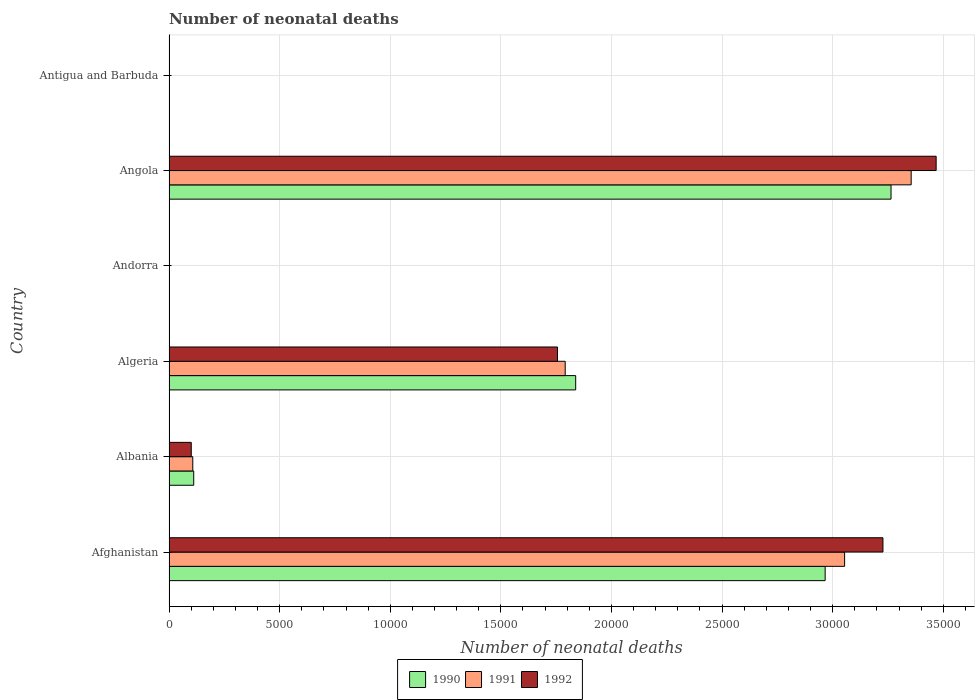How many different coloured bars are there?
Your answer should be very brief. 3. How many groups of bars are there?
Provide a succinct answer. 6. Are the number of bars on each tick of the Y-axis equal?
Offer a terse response. Yes. What is the label of the 2nd group of bars from the top?
Provide a succinct answer. Angola. In how many cases, is the number of bars for a given country not equal to the number of legend labels?
Give a very brief answer. 0. What is the number of neonatal deaths in in 1992 in Albania?
Make the answer very short. 1006. Across all countries, what is the maximum number of neonatal deaths in in 1991?
Your answer should be compact. 3.35e+04. Across all countries, what is the minimum number of neonatal deaths in in 1992?
Provide a short and direct response. 2. In which country was the number of neonatal deaths in in 1992 maximum?
Your answer should be very brief. Angola. In which country was the number of neonatal deaths in in 1992 minimum?
Ensure brevity in your answer.  Andorra. What is the total number of neonatal deaths in in 1990 in the graph?
Give a very brief answer. 8.18e+04. What is the difference between the number of neonatal deaths in in 1992 in Albania and that in Andorra?
Provide a short and direct response. 1004. What is the difference between the number of neonatal deaths in in 1991 in Antigua and Barbuda and the number of neonatal deaths in in 1992 in Angola?
Provide a succinct answer. -3.47e+04. What is the average number of neonatal deaths in in 1992 per country?
Ensure brevity in your answer.  1.43e+04. What is the difference between the number of neonatal deaths in in 1990 and number of neonatal deaths in in 1992 in Andorra?
Your answer should be compact. 0. What is the ratio of the number of neonatal deaths in in 1990 in Albania to that in Algeria?
Make the answer very short. 0.06. What is the difference between the highest and the second highest number of neonatal deaths in in 1992?
Your answer should be compact. 2404. What is the difference between the highest and the lowest number of neonatal deaths in in 1992?
Offer a terse response. 3.47e+04. In how many countries, is the number of neonatal deaths in in 1992 greater than the average number of neonatal deaths in in 1992 taken over all countries?
Offer a very short reply. 3. Is the sum of the number of neonatal deaths in in 1990 in Albania and Antigua and Barbuda greater than the maximum number of neonatal deaths in in 1992 across all countries?
Provide a short and direct response. No. What does the 1st bar from the top in Angola represents?
Make the answer very short. 1992. Are all the bars in the graph horizontal?
Your answer should be compact. Yes. Are the values on the major ticks of X-axis written in scientific E-notation?
Your answer should be compact. No. What is the title of the graph?
Your answer should be very brief. Number of neonatal deaths. What is the label or title of the X-axis?
Offer a very short reply. Number of neonatal deaths. What is the label or title of the Y-axis?
Provide a short and direct response. Country. What is the Number of neonatal deaths in 1990 in Afghanistan?
Your response must be concise. 2.97e+04. What is the Number of neonatal deaths of 1991 in Afghanistan?
Your answer should be compact. 3.05e+04. What is the Number of neonatal deaths in 1992 in Afghanistan?
Provide a short and direct response. 3.23e+04. What is the Number of neonatal deaths of 1990 in Albania?
Ensure brevity in your answer.  1117. What is the Number of neonatal deaths of 1991 in Albania?
Ensure brevity in your answer.  1075. What is the Number of neonatal deaths of 1992 in Albania?
Ensure brevity in your answer.  1006. What is the Number of neonatal deaths in 1990 in Algeria?
Your answer should be very brief. 1.84e+04. What is the Number of neonatal deaths of 1991 in Algeria?
Provide a succinct answer. 1.79e+04. What is the Number of neonatal deaths in 1992 in Algeria?
Offer a terse response. 1.76e+04. What is the Number of neonatal deaths of 1990 in Andorra?
Your answer should be very brief. 2. What is the Number of neonatal deaths of 1992 in Andorra?
Your answer should be very brief. 2. What is the Number of neonatal deaths in 1990 in Angola?
Ensure brevity in your answer.  3.26e+04. What is the Number of neonatal deaths in 1991 in Angola?
Make the answer very short. 3.35e+04. What is the Number of neonatal deaths of 1992 in Angola?
Provide a short and direct response. 3.47e+04. Across all countries, what is the maximum Number of neonatal deaths in 1990?
Offer a terse response. 3.26e+04. Across all countries, what is the maximum Number of neonatal deaths in 1991?
Your response must be concise. 3.35e+04. Across all countries, what is the maximum Number of neonatal deaths in 1992?
Your response must be concise. 3.47e+04. Across all countries, what is the minimum Number of neonatal deaths of 1991?
Give a very brief answer. 2. What is the total Number of neonatal deaths in 1990 in the graph?
Keep it short and to the point. 8.18e+04. What is the total Number of neonatal deaths in 1991 in the graph?
Give a very brief answer. 8.31e+04. What is the total Number of neonatal deaths in 1992 in the graph?
Keep it short and to the point. 8.55e+04. What is the difference between the Number of neonatal deaths of 1990 in Afghanistan and that in Albania?
Give a very brief answer. 2.85e+04. What is the difference between the Number of neonatal deaths of 1991 in Afghanistan and that in Albania?
Give a very brief answer. 2.95e+04. What is the difference between the Number of neonatal deaths in 1992 in Afghanistan and that in Albania?
Provide a succinct answer. 3.13e+04. What is the difference between the Number of neonatal deaths in 1990 in Afghanistan and that in Algeria?
Make the answer very short. 1.13e+04. What is the difference between the Number of neonatal deaths of 1991 in Afghanistan and that in Algeria?
Keep it short and to the point. 1.26e+04. What is the difference between the Number of neonatal deaths in 1992 in Afghanistan and that in Algeria?
Provide a short and direct response. 1.47e+04. What is the difference between the Number of neonatal deaths in 1990 in Afghanistan and that in Andorra?
Your answer should be very brief. 2.97e+04. What is the difference between the Number of neonatal deaths in 1991 in Afghanistan and that in Andorra?
Your response must be concise. 3.05e+04. What is the difference between the Number of neonatal deaths in 1992 in Afghanistan and that in Andorra?
Provide a short and direct response. 3.23e+04. What is the difference between the Number of neonatal deaths in 1990 in Afghanistan and that in Angola?
Your response must be concise. -2977. What is the difference between the Number of neonatal deaths in 1991 in Afghanistan and that in Angola?
Offer a very short reply. -3009. What is the difference between the Number of neonatal deaths of 1992 in Afghanistan and that in Angola?
Your answer should be compact. -2404. What is the difference between the Number of neonatal deaths in 1990 in Afghanistan and that in Antigua and Barbuda?
Offer a terse response. 2.96e+04. What is the difference between the Number of neonatal deaths in 1991 in Afghanistan and that in Antigua and Barbuda?
Offer a very short reply. 3.05e+04. What is the difference between the Number of neonatal deaths of 1992 in Afghanistan and that in Antigua and Barbuda?
Provide a succinct answer. 3.23e+04. What is the difference between the Number of neonatal deaths of 1990 in Albania and that in Algeria?
Your answer should be very brief. -1.73e+04. What is the difference between the Number of neonatal deaths in 1991 in Albania and that in Algeria?
Offer a terse response. -1.68e+04. What is the difference between the Number of neonatal deaths in 1992 in Albania and that in Algeria?
Keep it short and to the point. -1.66e+04. What is the difference between the Number of neonatal deaths of 1990 in Albania and that in Andorra?
Your answer should be compact. 1115. What is the difference between the Number of neonatal deaths in 1991 in Albania and that in Andorra?
Offer a terse response. 1073. What is the difference between the Number of neonatal deaths of 1992 in Albania and that in Andorra?
Offer a very short reply. 1004. What is the difference between the Number of neonatal deaths of 1990 in Albania and that in Angola?
Make the answer very short. -3.15e+04. What is the difference between the Number of neonatal deaths of 1991 in Albania and that in Angola?
Give a very brief answer. -3.25e+04. What is the difference between the Number of neonatal deaths of 1992 in Albania and that in Angola?
Offer a very short reply. -3.37e+04. What is the difference between the Number of neonatal deaths of 1990 in Albania and that in Antigua and Barbuda?
Provide a short and direct response. 1101. What is the difference between the Number of neonatal deaths of 1991 in Albania and that in Antigua and Barbuda?
Provide a short and direct response. 1060. What is the difference between the Number of neonatal deaths of 1992 in Albania and that in Antigua and Barbuda?
Your response must be concise. 992. What is the difference between the Number of neonatal deaths in 1990 in Algeria and that in Andorra?
Provide a short and direct response. 1.84e+04. What is the difference between the Number of neonatal deaths in 1991 in Algeria and that in Andorra?
Your answer should be compact. 1.79e+04. What is the difference between the Number of neonatal deaths of 1992 in Algeria and that in Andorra?
Give a very brief answer. 1.76e+04. What is the difference between the Number of neonatal deaths in 1990 in Algeria and that in Angola?
Your answer should be very brief. -1.43e+04. What is the difference between the Number of neonatal deaths of 1991 in Algeria and that in Angola?
Provide a short and direct response. -1.56e+04. What is the difference between the Number of neonatal deaths in 1992 in Algeria and that in Angola?
Your answer should be compact. -1.71e+04. What is the difference between the Number of neonatal deaths in 1990 in Algeria and that in Antigua and Barbuda?
Your answer should be compact. 1.84e+04. What is the difference between the Number of neonatal deaths of 1991 in Algeria and that in Antigua and Barbuda?
Offer a very short reply. 1.79e+04. What is the difference between the Number of neonatal deaths of 1992 in Algeria and that in Antigua and Barbuda?
Ensure brevity in your answer.  1.75e+04. What is the difference between the Number of neonatal deaths of 1990 in Andorra and that in Angola?
Provide a succinct answer. -3.26e+04. What is the difference between the Number of neonatal deaths of 1991 in Andorra and that in Angola?
Provide a short and direct response. -3.35e+04. What is the difference between the Number of neonatal deaths in 1992 in Andorra and that in Angola?
Give a very brief answer. -3.47e+04. What is the difference between the Number of neonatal deaths in 1990 in Andorra and that in Antigua and Barbuda?
Make the answer very short. -14. What is the difference between the Number of neonatal deaths in 1990 in Angola and that in Antigua and Barbuda?
Your answer should be compact. 3.26e+04. What is the difference between the Number of neonatal deaths of 1991 in Angola and that in Antigua and Barbuda?
Provide a short and direct response. 3.35e+04. What is the difference between the Number of neonatal deaths of 1992 in Angola and that in Antigua and Barbuda?
Keep it short and to the point. 3.47e+04. What is the difference between the Number of neonatal deaths in 1990 in Afghanistan and the Number of neonatal deaths in 1991 in Albania?
Keep it short and to the point. 2.86e+04. What is the difference between the Number of neonatal deaths of 1990 in Afghanistan and the Number of neonatal deaths of 1992 in Albania?
Keep it short and to the point. 2.87e+04. What is the difference between the Number of neonatal deaths in 1991 in Afghanistan and the Number of neonatal deaths in 1992 in Albania?
Your response must be concise. 2.95e+04. What is the difference between the Number of neonatal deaths of 1990 in Afghanistan and the Number of neonatal deaths of 1991 in Algeria?
Provide a short and direct response. 1.18e+04. What is the difference between the Number of neonatal deaths in 1990 in Afghanistan and the Number of neonatal deaths in 1992 in Algeria?
Ensure brevity in your answer.  1.21e+04. What is the difference between the Number of neonatal deaths in 1991 in Afghanistan and the Number of neonatal deaths in 1992 in Algeria?
Your response must be concise. 1.30e+04. What is the difference between the Number of neonatal deaths in 1990 in Afghanistan and the Number of neonatal deaths in 1991 in Andorra?
Your answer should be very brief. 2.97e+04. What is the difference between the Number of neonatal deaths of 1990 in Afghanistan and the Number of neonatal deaths of 1992 in Andorra?
Offer a terse response. 2.97e+04. What is the difference between the Number of neonatal deaths in 1991 in Afghanistan and the Number of neonatal deaths in 1992 in Andorra?
Give a very brief answer. 3.05e+04. What is the difference between the Number of neonatal deaths in 1990 in Afghanistan and the Number of neonatal deaths in 1991 in Angola?
Provide a short and direct response. -3888. What is the difference between the Number of neonatal deaths in 1990 in Afghanistan and the Number of neonatal deaths in 1992 in Angola?
Provide a short and direct response. -5016. What is the difference between the Number of neonatal deaths in 1991 in Afghanistan and the Number of neonatal deaths in 1992 in Angola?
Your answer should be very brief. -4137. What is the difference between the Number of neonatal deaths in 1990 in Afghanistan and the Number of neonatal deaths in 1991 in Antigua and Barbuda?
Keep it short and to the point. 2.96e+04. What is the difference between the Number of neonatal deaths in 1990 in Afghanistan and the Number of neonatal deaths in 1992 in Antigua and Barbuda?
Your answer should be compact. 2.96e+04. What is the difference between the Number of neonatal deaths in 1991 in Afghanistan and the Number of neonatal deaths in 1992 in Antigua and Barbuda?
Keep it short and to the point. 3.05e+04. What is the difference between the Number of neonatal deaths in 1990 in Albania and the Number of neonatal deaths in 1991 in Algeria?
Your response must be concise. -1.68e+04. What is the difference between the Number of neonatal deaths of 1990 in Albania and the Number of neonatal deaths of 1992 in Algeria?
Your answer should be very brief. -1.64e+04. What is the difference between the Number of neonatal deaths of 1991 in Albania and the Number of neonatal deaths of 1992 in Algeria?
Keep it short and to the point. -1.65e+04. What is the difference between the Number of neonatal deaths of 1990 in Albania and the Number of neonatal deaths of 1991 in Andorra?
Provide a succinct answer. 1115. What is the difference between the Number of neonatal deaths of 1990 in Albania and the Number of neonatal deaths of 1992 in Andorra?
Ensure brevity in your answer.  1115. What is the difference between the Number of neonatal deaths of 1991 in Albania and the Number of neonatal deaths of 1992 in Andorra?
Make the answer very short. 1073. What is the difference between the Number of neonatal deaths of 1990 in Albania and the Number of neonatal deaths of 1991 in Angola?
Make the answer very short. -3.24e+04. What is the difference between the Number of neonatal deaths in 1990 in Albania and the Number of neonatal deaths in 1992 in Angola?
Ensure brevity in your answer.  -3.36e+04. What is the difference between the Number of neonatal deaths in 1991 in Albania and the Number of neonatal deaths in 1992 in Angola?
Your answer should be compact. -3.36e+04. What is the difference between the Number of neonatal deaths in 1990 in Albania and the Number of neonatal deaths in 1991 in Antigua and Barbuda?
Keep it short and to the point. 1102. What is the difference between the Number of neonatal deaths in 1990 in Albania and the Number of neonatal deaths in 1992 in Antigua and Barbuda?
Your answer should be compact. 1103. What is the difference between the Number of neonatal deaths in 1991 in Albania and the Number of neonatal deaths in 1992 in Antigua and Barbuda?
Ensure brevity in your answer.  1061. What is the difference between the Number of neonatal deaths of 1990 in Algeria and the Number of neonatal deaths of 1991 in Andorra?
Your answer should be very brief. 1.84e+04. What is the difference between the Number of neonatal deaths of 1990 in Algeria and the Number of neonatal deaths of 1992 in Andorra?
Your answer should be very brief. 1.84e+04. What is the difference between the Number of neonatal deaths in 1991 in Algeria and the Number of neonatal deaths in 1992 in Andorra?
Ensure brevity in your answer.  1.79e+04. What is the difference between the Number of neonatal deaths of 1990 in Algeria and the Number of neonatal deaths of 1991 in Angola?
Your answer should be compact. -1.52e+04. What is the difference between the Number of neonatal deaths in 1990 in Algeria and the Number of neonatal deaths in 1992 in Angola?
Your response must be concise. -1.63e+04. What is the difference between the Number of neonatal deaths of 1991 in Algeria and the Number of neonatal deaths of 1992 in Angola?
Your answer should be compact. -1.68e+04. What is the difference between the Number of neonatal deaths in 1990 in Algeria and the Number of neonatal deaths in 1991 in Antigua and Barbuda?
Make the answer very short. 1.84e+04. What is the difference between the Number of neonatal deaths in 1990 in Algeria and the Number of neonatal deaths in 1992 in Antigua and Barbuda?
Your answer should be compact. 1.84e+04. What is the difference between the Number of neonatal deaths in 1991 in Algeria and the Number of neonatal deaths in 1992 in Antigua and Barbuda?
Ensure brevity in your answer.  1.79e+04. What is the difference between the Number of neonatal deaths of 1990 in Andorra and the Number of neonatal deaths of 1991 in Angola?
Keep it short and to the point. -3.35e+04. What is the difference between the Number of neonatal deaths in 1990 in Andorra and the Number of neonatal deaths in 1992 in Angola?
Provide a short and direct response. -3.47e+04. What is the difference between the Number of neonatal deaths in 1991 in Andorra and the Number of neonatal deaths in 1992 in Angola?
Your response must be concise. -3.47e+04. What is the difference between the Number of neonatal deaths of 1990 in Andorra and the Number of neonatal deaths of 1992 in Antigua and Barbuda?
Ensure brevity in your answer.  -12. What is the difference between the Number of neonatal deaths of 1991 in Andorra and the Number of neonatal deaths of 1992 in Antigua and Barbuda?
Your answer should be very brief. -12. What is the difference between the Number of neonatal deaths in 1990 in Angola and the Number of neonatal deaths in 1991 in Antigua and Barbuda?
Provide a short and direct response. 3.26e+04. What is the difference between the Number of neonatal deaths in 1990 in Angola and the Number of neonatal deaths in 1992 in Antigua and Barbuda?
Provide a succinct answer. 3.26e+04. What is the difference between the Number of neonatal deaths in 1991 in Angola and the Number of neonatal deaths in 1992 in Antigua and Barbuda?
Your response must be concise. 3.35e+04. What is the average Number of neonatal deaths of 1990 per country?
Your answer should be compact. 1.36e+04. What is the average Number of neonatal deaths of 1991 per country?
Make the answer very short. 1.38e+04. What is the average Number of neonatal deaths in 1992 per country?
Offer a terse response. 1.43e+04. What is the difference between the Number of neonatal deaths in 1990 and Number of neonatal deaths in 1991 in Afghanistan?
Make the answer very short. -879. What is the difference between the Number of neonatal deaths in 1990 and Number of neonatal deaths in 1992 in Afghanistan?
Offer a terse response. -2612. What is the difference between the Number of neonatal deaths in 1991 and Number of neonatal deaths in 1992 in Afghanistan?
Offer a terse response. -1733. What is the difference between the Number of neonatal deaths of 1990 and Number of neonatal deaths of 1991 in Albania?
Offer a terse response. 42. What is the difference between the Number of neonatal deaths of 1990 and Number of neonatal deaths of 1992 in Albania?
Ensure brevity in your answer.  111. What is the difference between the Number of neonatal deaths in 1990 and Number of neonatal deaths in 1991 in Algeria?
Provide a succinct answer. 474. What is the difference between the Number of neonatal deaths of 1990 and Number of neonatal deaths of 1992 in Algeria?
Give a very brief answer. 822. What is the difference between the Number of neonatal deaths of 1991 and Number of neonatal deaths of 1992 in Algeria?
Your answer should be very brief. 348. What is the difference between the Number of neonatal deaths of 1990 and Number of neonatal deaths of 1991 in Angola?
Keep it short and to the point. -911. What is the difference between the Number of neonatal deaths in 1990 and Number of neonatal deaths in 1992 in Angola?
Your response must be concise. -2039. What is the difference between the Number of neonatal deaths of 1991 and Number of neonatal deaths of 1992 in Angola?
Ensure brevity in your answer.  -1128. What is the difference between the Number of neonatal deaths of 1990 and Number of neonatal deaths of 1992 in Antigua and Barbuda?
Provide a succinct answer. 2. What is the difference between the Number of neonatal deaths of 1991 and Number of neonatal deaths of 1992 in Antigua and Barbuda?
Make the answer very short. 1. What is the ratio of the Number of neonatal deaths of 1990 in Afghanistan to that in Albania?
Provide a succinct answer. 26.55. What is the ratio of the Number of neonatal deaths in 1991 in Afghanistan to that in Albania?
Give a very brief answer. 28.41. What is the ratio of the Number of neonatal deaths in 1992 in Afghanistan to that in Albania?
Provide a succinct answer. 32.08. What is the ratio of the Number of neonatal deaths of 1990 in Afghanistan to that in Algeria?
Your response must be concise. 1.61. What is the ratio of the Number of neonatal deaths of 1991 in Afghanistan to that in Algeria?
Your answer should be very brief. 1.71. What is the ratio of the Number of neonatal deaths of 1992 in Afghanistan to that in Algeria?
Keep it short and to the point. 1.84. What is the ratio of the Number of neonatal deaths of 1990 in Afghanistan to that in Andorra?
Your response must be concise. 1.48e+04. What is the ratio of the Number of neonatal deaths in 1991 in Afghanistan to that in Andorra?
Your answer should be compact. 1.53e+04. What is the ratio of the Number of neonatal deaths of 1992 in Afghanistan to that in Andorra?
Your answer should be very brief. 1.61e+04. What is the ratio of the Number of neonatal deaths in 1990 in Afghanistan to that in Angola?
Your answer should be compact. 0.91. What is the ratio of the Number of neonatal deaths of 1991 in Afghanistan to that in Angola?
Your answer should be compact. 0.91. What is the ratio of the Number of neonatal deaths in 1992 in Afghanistan to that in Angola?
Your answer should be compact. 0.93. What is the ratio of the Number of neonatal deaths of 1990 in Afghanistan to that in Antigua and Barbuda?
Provide a short and direct response. 1853.62. What is the ratio of the Number of neonatal deaths in 1991 in Afghanistan to that in Antigua and Barbuda?
Make the answer very short. 2035.8. What is the ratio of the Number of neonatal deaths of 1992 in Afghanistan to that in Antigua and Barbuda?
Ensure brevity in your answer.  2305. What is the ratio of the Number of neonatal deaths in 1990 in Albania to that in Algeria?
Your answer should be compact. 0.06. What is the ratio of the Number of neonatal deaths in 1992 in Albania to that in Algeria?
Your answer should be very brief. 0.06. What is the ratio of the Number of neonatal deaths of 1990 in Albania to that in Andorra?
Your answer should be compact. 558.5. What is the ratio of the Number of neonatal deaths in 1991 in Albania to that in Andorra?
Keep it short and to the point. 537.5. What is the ratio of the Number of neonatal deaths in 1992 in Albania to that in Andorra?
Provide a short and direct response. 503. What is the ratio of the Number of neonatal deaths of 1990 in Albania to that in Angola?
Ensure brevity in your answer.  0.03. What is the ratio of the Number of neonatal deaths of 1991 in Albania to that in Angola?
Give a very brief answer. 0.03. What is the ratio of the Number of neonatal deaths of 1992 in Albania to that in Angola?
Offer a terse response. 0.03. What is the ratio of the Number of neonatal deaths of 1990 in Albania to that in Antigua and Barbuda?
Your answer should be compact. 69.81. What is the ratio of the Number of neonatal deaths in 1991 in Albania to that in Antigua and Barbuda?
Your answer should be compact. 71.67. What is the ratio of the Number of neonatal deaths of 1992 in Albania to that in Antigua and Barbuda?
Offer a very short reply. 71.86. What is the ratio of the Number of neonatal deaths of 1990 in Algeria to that in Andorra?
Offer a very short reply. 9191. What is the ratio of the Number of neonatal deaths of 1991 in Algeria to that in Andorra?
Keep it short and to the point. 8954. What is the ratio of the Number of neonatal deaths in 1992 in Algeria to that in Andorra?
Offer a very short reply. 8780. What is the ratio of the Number of neonatal deaths of 1990 in Algeria to that in Angola?
Make the answer very short. 0.56. What is the ratio of the Number of neonatal deaths of 1991 in Algeria to that in Angola?
Provide a succinct answer. 0.53. What is the ratio of the Number of neonatal deaths in 1992 in Algeria to that in Angola?
Ensure brevity in your answer.  0.51. What is the ratio of the Number of neonatal deaths of 1990 in Algeria to that in Antigua and Barbuda?
Your answer should be compact. 1148.88. What is the ratio of the Number of neonatal deaths of 1991 in Algeria to that in Antigua and Barbuda?
Offer a very short reply. 1193.87. What is the ratio of the Number of neonatal deaths in 1992 in Algeria to that in Antigua and Barbuda?
Make the answer very short. 1254.29. What is the ratio of the Number of neonatal deaths in 1991 in Andorra to that in Antigua and Barbuda?
Offer a very short reply. 0.13. What is the ratio of the Number of neonatal deaths in 1992 in Andorra to that in Antigua and Barbuda?
Your answer should be very brief. 0.14. What is the ratio of the Number of neonatal deaths of 1990 in Angola to that in Antigua and Barbuda?
Keep it short and to the point. 2039.69. What is the ratio of the Number of neonatal deaths of 1991 in Angola to that in Antigua and Barbuda?
Provide a short and direct response. 2236.4. What is the ratio of the Number of neonatal deaths of 1992 in Angola to that in Antigua and Barbuda?
Your answer should be compact. 2476.71. What is the difference between the highest and the second highest Number of neonatal deaths of 1990?
Keep it short and to the point. 2977. What is the difference between the highest and the second highest Number of neonatal deaths of 1991?
Keep it short and to the point. 3009. What is the difference between the highest and the second highest Number of neonatal deaths of 1992?
Your answer should be very brief. 2404. What is the difference between the highest and the lowest Number of neonatal deaths of 1990?
Your answer should be compact. 3.26e+04. What is the difference between the highest and the lowest Number of neonatal deaths of 1991?
Make the answer very short. 3.35e+04. What is the difference between the highest and the lowest Number of neonatal deaths of 1992?
Your answer should be very brief. 3.47e+04. 